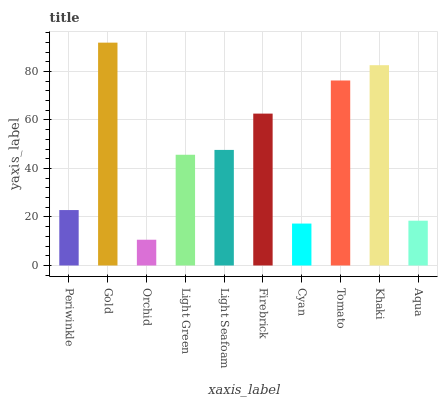Is Gold the minimum?
Answer yes or no. No. Is Orchid the maximum?
Answer yes or no. No. Is Gold greater than Orchid?
Answer yes or no. Yes. Is Orchid less than Gold?
Answer yes or no. Yes. Is Orchid greater than Gold?
Answer yes or no. No. Is Gold less than Orchid?
Answer yes or no. No. Is Light Seafoam the high median?
Answer yes or no. Yes. Is Light Green the low median?
Answer yes or no. Yes. Is Cyan the high median?
Answer yes or no. No. Is Light Seafoam the low median?
Answer yes or no. No. 